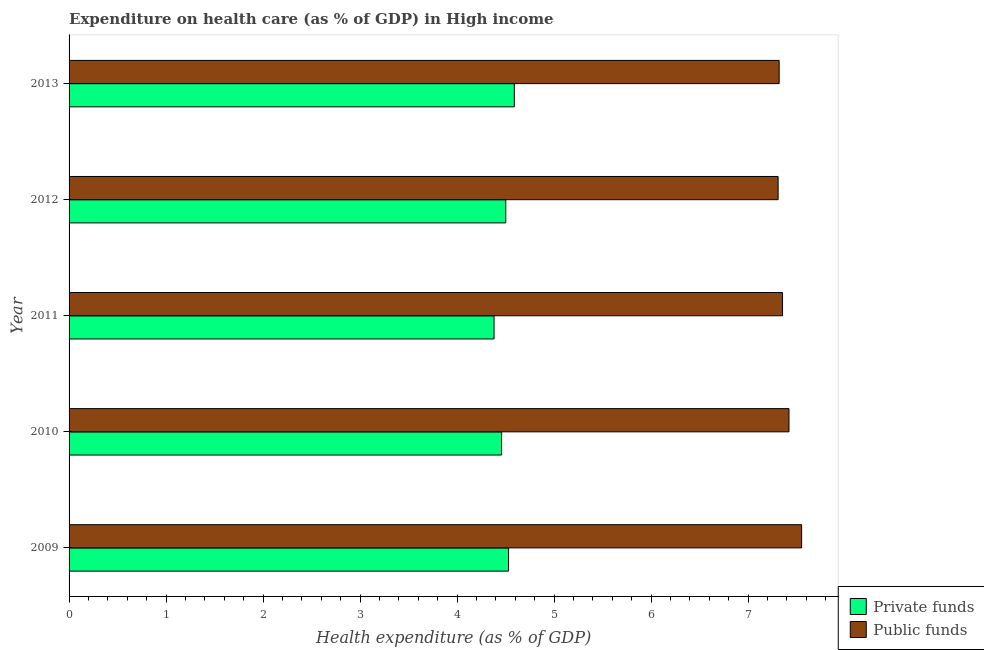Are the number of bars on each tick of the Y-axis equal?
Your response must be concise. Yes. How many bars are there on the 5th tick from the top?
Give a very brief answer. 2. What is the amount of private funds spent in healthcare in 2010?
Ensure brevity in your answer.  4.46. Across all years, what is the maximum amount of private funds spent in healthcare?
Your answer should be very brief. 4.59. Across all years, what is the minimum amount of private funds spent in healthcare?
Give a very brief answer. 4.38. In which year was the amount of private funds spent in healthcare maximum?
Your response must be concise. 2013. What is the total amount of public funds spent in healthcare in the graph?
Provide a short and direct response. 36.96. What is the difference between the amount of private funds spent in healthcare in 2012 and that in 2013?
Offer a very short reply. -0.09. What is the difference between the amount of public funds spent in healthcare in 2010 and the amount of private funds spent in healthcare in 2011?
Your answer should be compact. 3.04. What is the average amount of public funds spent in healthcare per year?
Offer a terse response. 7.39. In the year 2010, what is the difference between the amount of private funds spent in healthcare and amount of public funds spent in healthcare?
Keep it short and to the point. -2.96. What is the ratio of the amount of public funds spent in healthcare in 2011 to that in 2013?
Make the answer very short. 1. Is the amount of private funds spent in healthcare in 2009 less than that in 2012?
Your answer should be very brief. No. Is the difference between the amount of private funds spent in healthcare in 2010 and 2012 greater than the difference between the amount of public funds spent in healthcare in 2010 and 2012?
Ensure brevity in your answer.  No. What is the difference between the highest and the second highest amount of private funds spent in healthcare?
Make the answer very short. 0.06. What is the difference between the highest and the lowest amount of private funds spent in healthcare?
Offer a very short reply. 0.21. In how many years, is the amount of public funds spent in healthcare greater than the average amount of public funds spent in healthcare taken over all years?
Offer a very short reply. 2. Is the sum of the amount of private funds spent in healthcare in 2010 and 2011 greater than the maximum amount of public funds spent in healthcare across all years?
Make the answer very short. Yes. What does the 2nd bar from the top in 2011 represents?
Ensure brevity in your answer.  Private funds. What does the 1st bar from the bottom in 2012 represents?
Offer a terse response. Private funds. How many bars are there?
Your answer should be very brief. 10. How many years are there in the graph?
Offer a terse response. 5. What is the difference between two consecutive major ticks on the X-axis?
Offer a terse response. 1. Are the values on the major ticks of X-axis written in scientific E-notation?
Your answer should be very brief. No. Does the graph contain grids?
Your response must be concise. No. Where does the legend appear in the graph?
Give a very brief answer. Bottom right. What is the title of the graph?
Offer a terse response. Expenditure on health care (as % of GDP) in High income. Does "Formally registered" appear as one of the legend labels in the graph?
Provide a succinct answer. No. What is the label or title of the X-axis?
Your response must be concise. Health expenditure (as % of GDP). What is the label or title of the Y-axis?
Offer a terse response. Year. What is the Health expenditure (as % of GDP) of Private funds in 2009?
Give a very brief answer. 4.53. What is the Health expenditure (as % of GDP) of Public funds in 2009?
Offer a very short reply. 7.55. What is the Health expenditure (as % of GDP) of Private funds in 2010?
Your answer should be compact. 4.46. What is the Health expenditure (as % of GDP) of Public funds in 2010?
Your response must be concise. 7.42. What is the Health expenditure (as % of GDP) in Private funds in 2011?
Make the answer very short. 4.38. What is the Health expenditure (as % of GDP) in Public funds in 2011?
Make the answer very short. 7.36. What is the Health expenditure (as % of GDP) of Private funds in 2012?
Your answer should be compact. 4.5. What is the Health expenditure (as % of GDP) of Public funds in 2012?
Keep it short and to the point. 7.31. What is the Health expenditure (as % of GDP) in Private funds in 2013?
Offer a very short reply. 4.59. What is the Health expenditure (as % of GDP) in Public funds in 2013?
Your answer should be compact. 7.32. Across all years, what is the maximum Health expenditure (as % of GDP) of Private funds?
Make the answer very short. 4.59. Across all years, what is the maximum Health expenditure (as % of GDP) in Public funds?
Keep it short and to the point. 7.55. Across all years, what is the minimum Health expenditure (as % of GDP) of Private funds?
Make the answer very short. 4.38. Across all years, what is the minimum Health expenditure (as % of GDP) in Public funds?
Your answer should be compact. 7.31. What is the total Health expenditure (as % of GDP) of Private funds in the graph?
Your answer should be compact. 22.46. What is the total Health expenditure (as % of GDP) in Public funds in the graph?
Your answer should be compact. 36.96. What is the difference between the Health expenditure (as % of GDP) in Private funds in 2009 and that in 2010?
Ensure brevity in your answer.  0.07. What is the difference between the Health expenditure (as % of GDP) of Public funds in 2009 and that in 2010?
Keep it short and to the point. 0.13. What is the difference between the Health expenditure (as % of GDP) of Private funds in 2009 and that in 2011?
Offer a terse response. 0.15. What is the difference between the Health expenditure (as % of GDP) of Public funds in 2009 and that in 2011?
Provide a short and direct response. 0.2. What is the difference between the Health expenditure (as % of GDP) of Private funds in 2009 and that in 2012?
Offer a terse response. 0.03. What is the difference between the Health expenditure (as % of GDP) in Public funds in 2009 and that in 2012?
Offer a very short reply. 0.24. What is the difference between the Health expenditure (as % of GDP) of Private funds in 2009 and that in 2013?
Your response must be concise. -0.06. What is the difference between the Health expenditure (as % of GDP) of Public funds in 2009 and that in 2013?
Your answer should be compact. 0.23. What is the difference between the Health expenditure (as % of GDP) of Private funds in 2010 and that in 2011?
Make the answer very short. 0.08. What is the difference between the Health expenditure (as % of GDP) in Public funds in 2010 and that in 2011?
Your answer should be compact. 0.07. What is the difference between the Health expenditure (as % of GDP) in Private funds in 2010 and that in 2012?
Your answer should be very brief. -0.04. What is the difference between the Health expenditure (as % of GDP) in Public funds in 2010 and that in 2012?
Offer a terse response. 0.11. What is the difference between the Health expenditure (as % of GDP) in Private funds in 2010 and that in 2013?
Provide a short and direct response. -0.13. What is the difference between the Health expenditure (as % of GDP) of Public funds in 2010 and that in 2013?
Make the answer very short. 0.1. What is the difference between the Health expenditure (as % of GDP) in Private funds in 2011 and that in 2012?
Keep it short and to the point. -0.12. What is the difference between the Health expenditure (as % of GDP) of Public funds in 2011 and that in 2012?
Offer a very short reply. 0.05. What is the difference between the Health expenditure (as % of GDP) of Private funds in 2011 and that in 2013?
Provide a succinct answer. -0.21. What is the difference between the Health expenditure (as % of GDP) of Public funds in 2011 and that in 2013?
Make the answer very short. 0.03. What is the difference between the Health expenditure (as % of GDP) in Private funds in 2012 and that in 2013?
Your answer should be very brief. -0.09. What is the difference between the Health expenditure (as % of GDP) of Public funds in 2012 and that in 2013?
Offer a very short reply. -0.01. What is the difference between the Health expenditure (as % of GDP) in Private funds in 2009 and the Health expenditure (as % of GDP) in Public funds in 2010?
Provide a succinct answer. -2.89. What is the difference between the Health expenditure (as % of GDP) in Private funds in 2009 and the Health expenditure (as % of GDP) in Public funds in 2011?
Your answer should be very brief. -2.82. What is the difference between the Health expenditure (as % of GDP) in Private funds in 2009 and the Health expenditure (as % of GDP) in Public funds in 2012?
Ensure brevity in your answer.  -2.78. What is the difference between the Health expenditure (as % of GDP) in Private funds in 2009 and the Health expenditure (as % of GDP) in Public funds in 2013?
Provide a short and direct response. -2.79. What is the difference between the Health expenditure (as % of GDP) in Private funds in 2010 and the Health expenditure (as % of GDP) in Public funds in 2011?
Your response must be concise. -2.9. What is the difference between the Health expenditure (as % of GDP) of Private funds in 2010 and the Health expenditure (as % of GDP) of Public funds in 2012?
Offer a terse response. -2.85. What is the difference between the Health expenditure (as % of GDP) in Private funds in 2010 and the Health expenditure (as % of GDP) in Public funds in 2013?
Offer a very short reply. -2.86. What is the difference between the Health expenditure (as % of GDP) in Private funds in 2011 and the Health expenditure (as % of GDP) in Public funds in 2012?
Keep it short and to the point. -2.93. What is the difference between the Health expenditure (as % of GDP) of Private funds in 2011 and the Health expenditure (as % of GDP) of Public funds in 2013?
Make the answer very short. -2.94. What is the difference between the Health expenditure (as % of GDP) of Private funds in 2012 and the Health expenditure (as % of GDP) of Public funds in 2013?
Your answer should be compact. -2.82. What is the average Health expenditure (as % of GDP) of Private funds per year?
Your answer should be compact. 4.49. What is the average Health expenditure (as % of GDP) in Public funds per year?
Offer a very short reply. 7.39. In the year 2009, what is the difference between the Health expenditure (as % of GDP) in Private funds and Health expenditure (as % of GDP) in Public funds?
Offer a very short reply. -3.02. In the year 2010, what is the difference between the Health expenditure (as % of GDP) of Private funds and Health expenditure (as % of GDP) of Public funds?
Offer a terse response. -2.96. In the year 2011, what is the difference between the Health expenditure (as % of GDP) of Private funds and Health expenditure (as % of GDP) of Public funds?
Provide a succinct answer. -2.97. In the year 2012, what is the difference between the Health expenditure (as % of GDP) in Private funds and Health expenditure (as % of GDP) in Public funds?
Provide a succinct answer. -2.81. In the year 2013, what is the difference between the Health expenditure (as % of GDP) in Private funds and Health expenditure (as % of GDP) in Public funds?
Ensure brevity in your answer.  -2.73. What is the ratio of the Health expenditure (as % of GDP) of Private funds in 2009 to that in 2010?
Provide a short and direct response. 1.02. What is the ratio of the Health expenditure (as % of GDP) in Public funds in 2009 to that in 2010?
Your answer should be very brief. 1.02. What is the ratio of the Health expenditure (as % of GDP) of Private funds in 2009 to that in 2011?
Offer a very short reply. 1.03. What is the ratio of the Health expenditure (as % of GDP) in Public funds in 2009 to that in 2011?
Provide a short and direct response. 1.03. What is the ratio of the Health expenditure (as % of GDP) of Private funds in 2009 to that in 2012?
Ensure brevity in your answer.  1.01. What is the ratio of the Health expenditure (as % of GDP) in Public funds in 2009 to that in 2012?
Your response must be concise. 1.03. What is the ratio of the Health expenditure (as % of GDP) in Private funds in 2009 to that in 2013?
Your answer should be compact. 0.99. What is the ratio of the Health expenditure (as % of GDP) of Public funds in 2009 to that in 2013?
Give a very brief answer. 1.03. What is the ratio of the Health expenditure (as % of GDP) of Private funds in 2010 to that in 2011?
Keep it short and to the point. 1.02. What is the ratio of the Health expenditure (as % of GDP) in Public funds in 2010 to that in 2012?
Make the answer very short. 1.02. What is the ratio of the Health expenditure (as % of GDP) in Private funds in 2010 to that in 2013?
Offer a very short reply. 0.97. What is the ratio of the Health expenditure (as % of GDP) of Public funds in 2010 to that in 2013?
Offer a very short reply. 1.01. What is the ratio of the Health expenditure (as % of GDP) of Private funds in 2011 to that in 2012?
Ensure brevity in your answer.  0.97. What is the ratio of the Health expenditure (as % of GDP) in Public funds in 2011 to that in 2012?
Ensure brevity in your answer.  1.01. What is the ratio of the Health expenditure (as % of GDP) in Private funds in 2011 to that in 2013?
Offer a terse response. 0.95. What is the ratio of the Health expenditure (as % of GDP) of Private funds in 2012 to that in 2013?
Provide a succinct answer. 0.98. What is the difference between the highest and the second highest Health expenditure (as % of GDP) of Private funds?
Your answer should be compact. 0.06. What is the difference between the highest and the second highest Health expenditure (as % of GDP) of Public funds?
Your response must be concise. 0.13. What is the difference between the highest and the lowest Health expenditure (as % of GDP) of Private funds?
Offer a terse response. 0.21. What is the difference between the highest and the lowest Health expenditure (as % of GDP) in Public funds?
Make the answer very short. 0.24. 